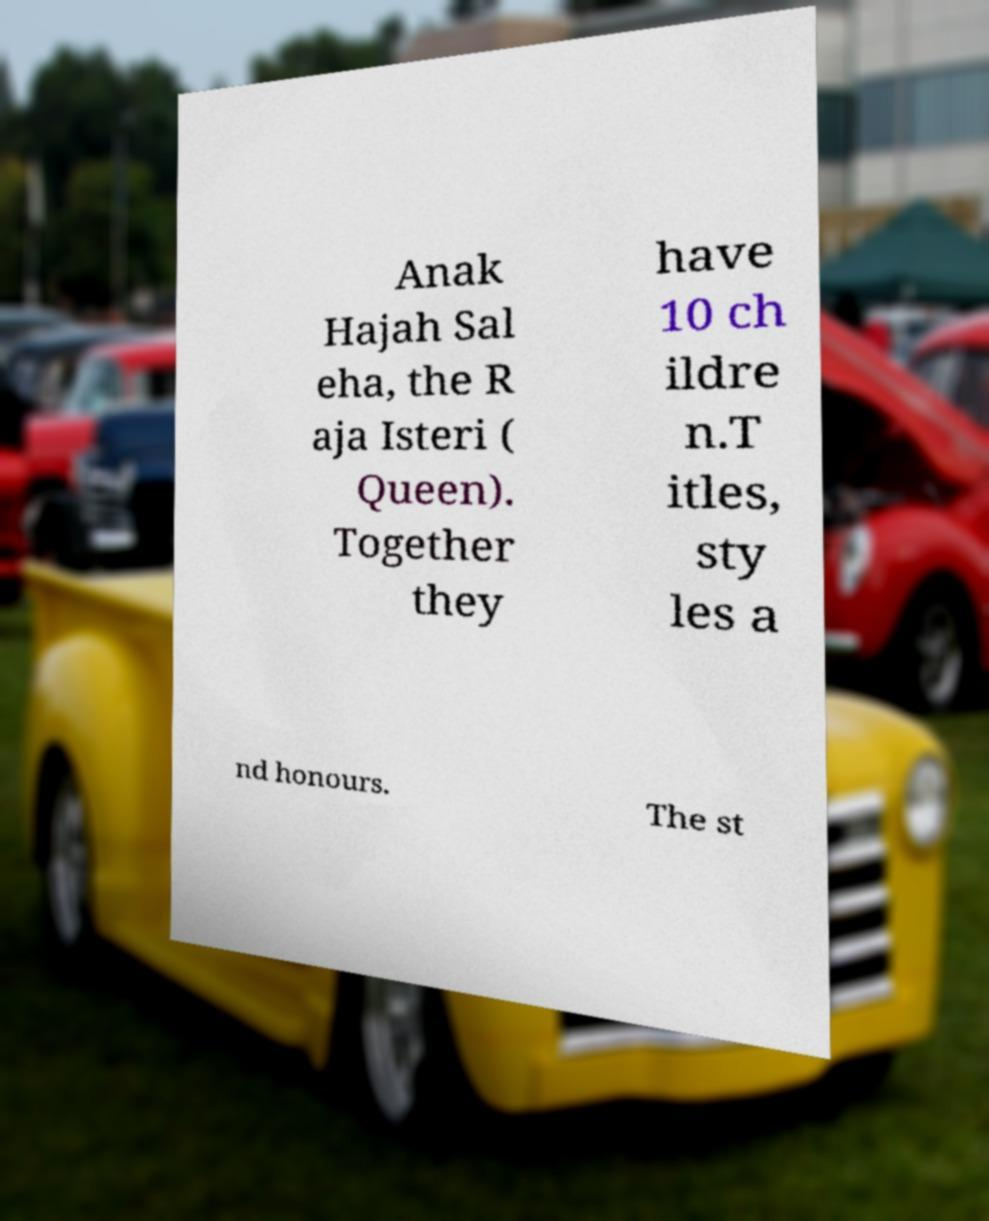Please identify and transcribe the text found in this image. Anak Hajah Sal eha, the R aja Isteri ( Queen). Together they have 10 ch ildre n.T itles, sty les a nd honours. The st 